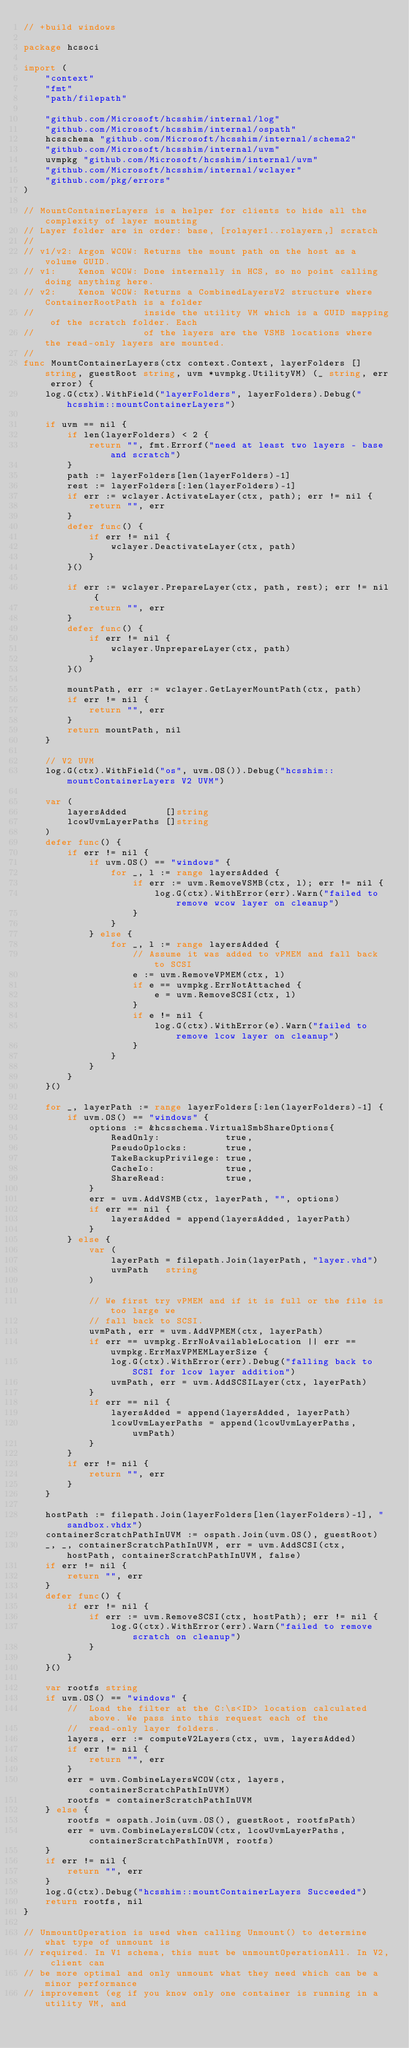Convert code to text. <code><loc_0><loc_0><loc_500><loc_500><_Go_>// +build windows

package hcsoci

import (
	"context"
	"fmt"
	"path/filepath"

	"github.com/Microsoft/hcsshim/internal/log"
	"github.com/Microsoft/hcsshim/internal/ospath"
	hcsschema "github.com/Microsoft/hcsshim/internal/schema2"
	"github.com/Microsoft/hcsshim/internal/uvm"
	uvmpkg "github.com/Microsoft/hcsshim/internal/uvm"
	"github.com/Microsoft/hcsshim/internal/wclayer"
	"github.com/pkg/errors"
)

// MountContainerLayers is a helper for clients to hide all the complexity of layer mounting
// Layer folder are in order: base, [rolayer1..rolayern,] scratch
//
// v1/v2: Argon WCOW: Returns the mount path on the host as a volume GUID.
// v1:    Xenon WCOW: Done internally in HCS, so no point calling doing anything here.
// v2:    Xenon WCOW: Returns a CombinedLayersV2 structure where ContainerRootPath is a folder
//                    inside the utility VM which is a GUID mapping of the scratch folder. Each
//                    of the layers are the VSMB locations where the read-only layers are mounted.
//
func MountContainerLayers(ctx context.Context, layerFolders []string, guestRoot string, uvm *uvmpkg.UtilityVM) (_ string, err error) {
	log.G(ctx).WithField("layerFolders", layerFolders).Debug("hcsshim::mountContainerLayers")

	if uvm == nil {
		if len(layerFolders) < 2 {
			return "", fmt.Errorf("need at least two layers - base and scratch")
		}
		path := layerFolders[len(layerFolders)-1]
		rest := layerFolders[:len(layerFolders)-1]
		if err := wclayer.ActivateLayer(ctx, path); err != nil {
			return "", err
		}
		defer func() {
			if err != nil {
				wclayer.DeactivateLayer(ctx, path)
			}
		}()

		if err := wclayer.PrepareLayer(ctx, path, rest); err != nil {
			return "", err
		}
		defer func() {
			if err != nil {
				wclayer.UnprepareLayer(ctx, path)
			}
		}()

		mountPath, err := wclayer.GetLayerMountPath(ctx, path)
		if err != nil {
			return "", err
		}
		return mountPath, nil
	}

	// V2 UVM
	log.G(ctx).WithField("os", uvm.OS()).Debug("hcsshim::mountContainerLayers V2 UVM")

	var (
		layersAdded       []string
		lcowUvmLayerPaths []string
	)
	defer func() {
		if err != nil {
			if uvm.OS() == "windows" {
				for _, l := range layersAdded {
					if err := uvm.RemoveVSMB(ctx, l); err != nil {
						log.G(ctx).WithError(err).Warn("failed to remove wcow layer on cleanup")
					}
				}
			} else {
				for _, l := range layersAdded {
					// Assume it was added to vPMEM and fall back to SCSI
					e := uvm.RemoveVPMEM(ctx, l)
					if e == uvmpkg.ErrNotAttached {
						e = uvm.RemoveSCSI(ctx, l)
					}
					if e != nil {
						log.G(ctx).WithError(e).Warn("failed to remove lcow layer on cleanup")
					}
				}
			}
		}
	}()

	for _, layerPath := range layerFolders[:len(layerFolders)-1] {
		if uvm.OS() == "windows" {
			options := &hcsschema.VirtualSmbShareOptions{
				ReadOnly:            true,
				PseudoOplocks:       true,
				TakeBackupPrivilege: true,
				CacheIo:             true,
				ShareRead:           true,
			}
			err = uvm.AddVSMB(ctx, layerPath, "", options)
			if err == nil {
				layersAdded = append(layersAdded, layerPath)
			}
		} else {
			var (
				layerPath = filepath.Join(layerPath, "layer.vhd")
				uvmPath   string
			)

			// We first try vPMEM and if it is full or the file is too large we
			// fall back to SCSI.
			uvmPath, err = uvm.AddVPMEM(ctx, layerPath)
			if err == uvmpkg.ErrNoAvailableLocation || err == uvmpkg.ErrMaxVPMEMLayerSize {
				log.G(ctx).WithError(err).Debug("falling back to SCSI for lcow layer addition")
				uvmPath, err = uvm.AddSCSILayer(ctx, layerPath)
			}
			if err == nil {
				layersAdded = append(layersAdded, layerPath)
				lcowUvmLayerPaths = append(lcowUvmLayerPaths, uvmPath)
			}
		}
		if err != nil {
			return "", err
		}
	}

	hostPath := filepath.Join(layerFolders[len(layerFolders)-1], "sandbox.vhdx")
	containerScratchPathInUVM := ospath.Join(uvm.OS(), guestRoot)
	_, _, containerScratchPathInUVM, err = uvm.AddSCSI(ctx, hostPath, containerScratchPathInUVM, false)
	if err != nil {
		return "", err
	}
	defer func() {
		if err != nil {
			if err := uvm.RemoveSCSI(ctx, hostPath); err != nil {
				log.G(ctx).WithError(err).Warn("failed to remove scratch on cleanup")
			}
		}
	}()

	var rootfs string
	if uvm.OS() == "windows" {
		// 	Load the filter at the C:\s<ID> location calculated above. We pass into this request each of the
		// 	read-only layer folders.
		layers, err := computeV2Layers(ctx, uvm, layersAdded)
		if err != nil {
			return "", err
		}
		err = uvm.CombineLayersWCOW(ctx, layers, containerScratchPathInUVM)
		rootfs = containerScratchPathInUVM
	} else {
		rootfs = ospath.Join(uvm.OS(), guestRoot, rootfsPath)
		err = uvm.CombineLayersLCOW(ctx, lcowUvmLayerPaths, containerScratchPathInUVM, rootfs)
	}
	if err != nil {
		return "", err
	}
	log.G(ctx).Debug("hcsshim::mountContainerLayers Succeeded")
	return rootfs, nil
}

// UnmountOperation is used when calling Unmount() to determine what type of unmount is
// required. In V1 schema, this must be unmountOperationAll. In V2, client can
// be more optimal and only unmount what they need which can be a minor performance
// improvement (eg if you know only one container is running in a utility VM, and</code> 